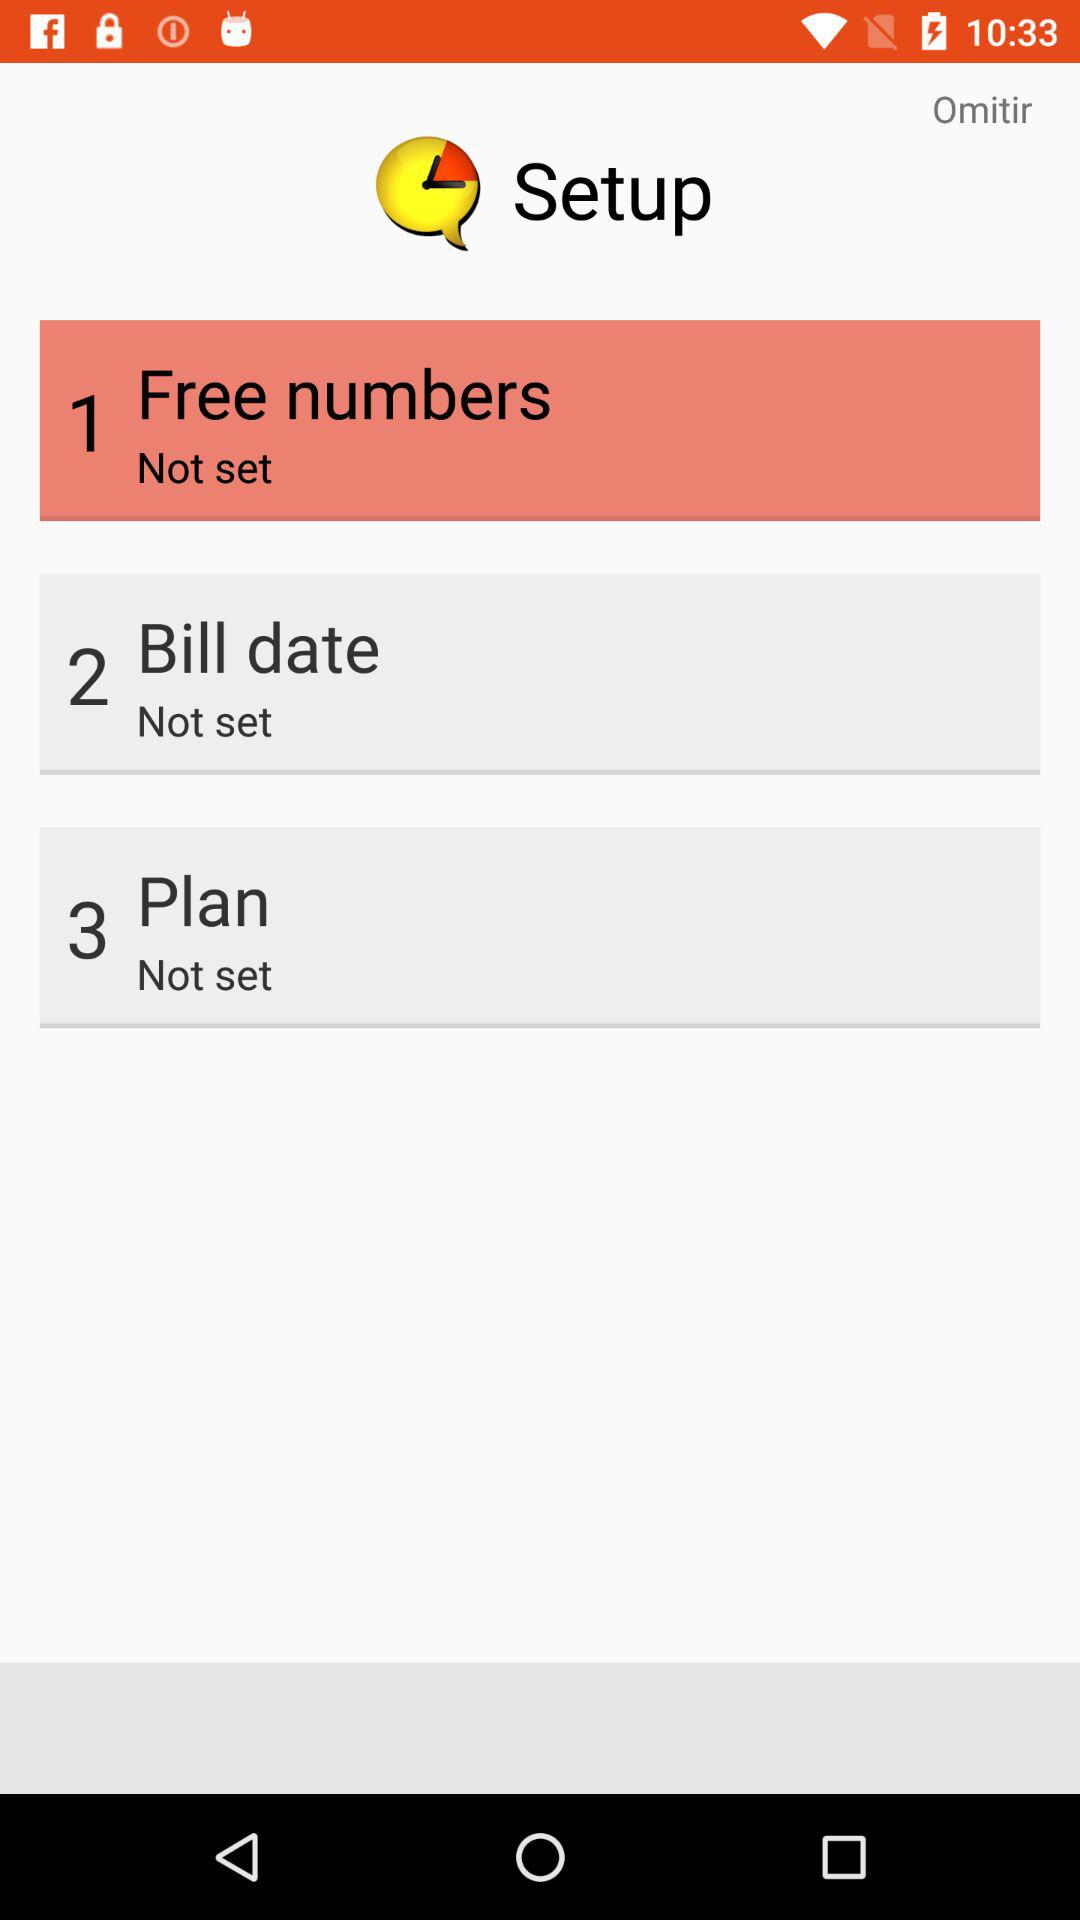What is the setting for the plan? The setting is "Not set". 